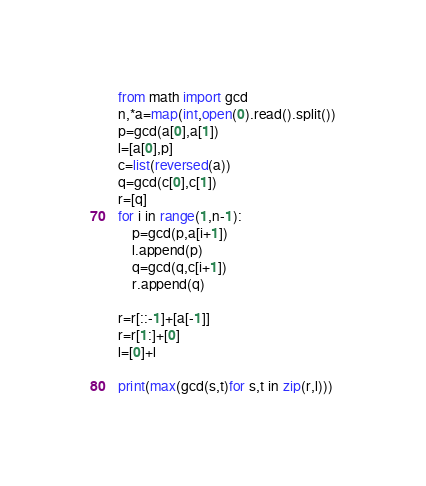Convert code to text. <code><loc_0><loc_0><loc_500><loc_500><_Python_>from math import gcd
n,*a=map(int,open(0).read().split())
p=gcd(a[0],a[1])
l=[a[0],p]
c=list(reversed(a))
q=gcd(c[0],c[1])
r=[q]
for i in range(1,n-1):
    p=gcd(p,a[i+1])
    l.append(p)
    q=gcd(q,c[i+1])
    r.append(q)

r=r[::-1]+[a[-1]]
r=r[1:]+[0]
l=[0]+l

print(max(gcd(s,t)for s,t in zip(r,l)))</code> 